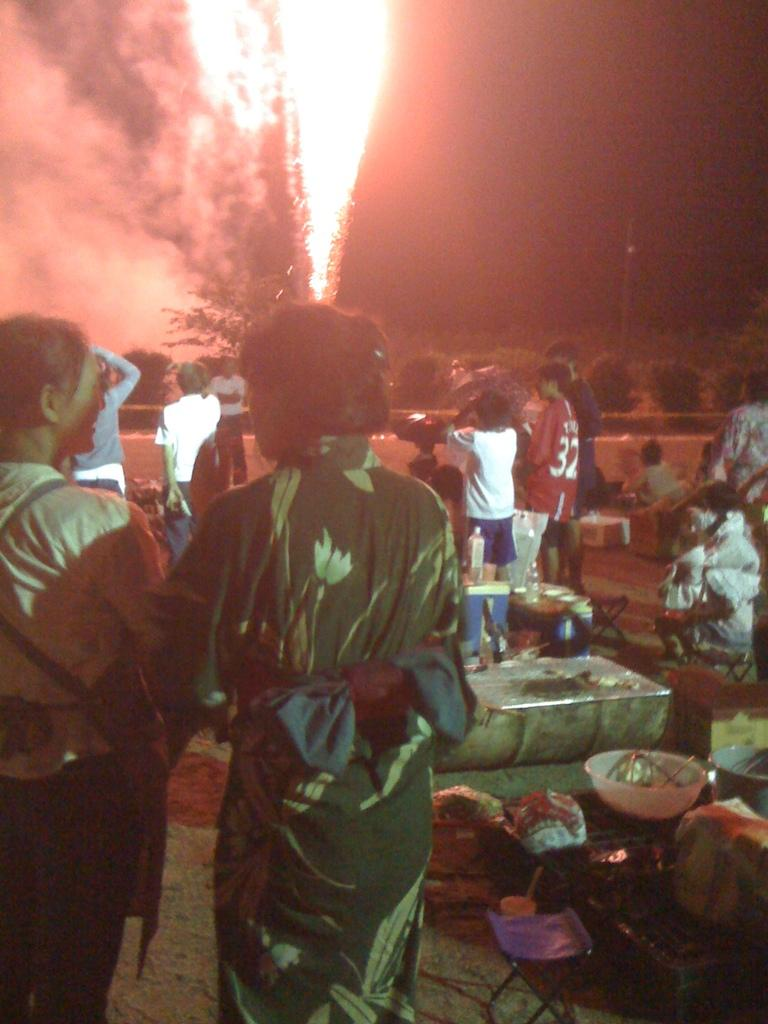How many women are in the front of the image? There are two women standing in the front of the image. What is happening behind the women? There is a group of people behind the women. What are the people in the group doing? The people in the group are standing and firing crackers. What type of quill is the girl holding in the image? There is no girl or quill present in the image. 